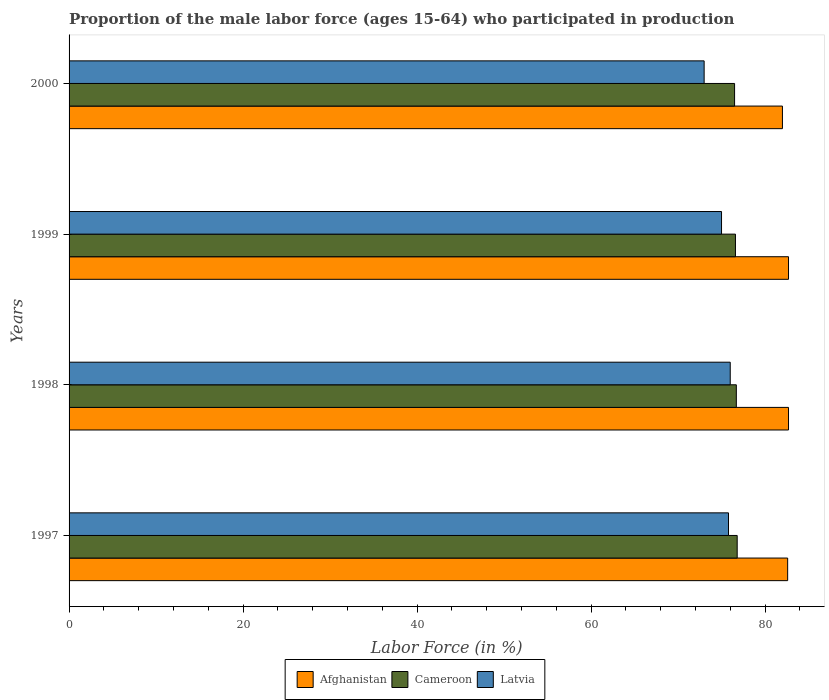How many different coloured bars are there?
Offer a terse response. 3. Are the number of bars per tick equal to the number of legend labels?
Provide a succinct answer. Yes. Are the number of bars on each tick of the Y-axis equal?
Your response must be concise. Yes. In how many cases, is the number of bars for a given year not equal to the number of legend labels?
Provide a succinct answer. 0. What is the proportion of the male labor force who participated in production in Afghanistan in 1998?
Ensure brevity in your answer.  82.7. Across all years, what is the maximum proportion of the male labor force who participated in production in Latvia?
Provide a short and direct response. 76. Across all years, what is the minimum proportion of the male labor force who participated in production in Latvia?
Offer a very short reply. 73. In which year was the proportion of the male labor force who participated in production in Afghanistan maximum?
Provide a short and direct response. 1998. In which year was the proportion of the male labor force who participated in production in Cameroon minimum?
Your answer should be compact. 2000. What is the total proportion of the male labor force who participated in production in Cameroon in the graph?
Offer a terse response. 306.6. What is the difference between the proportion of the male labor force who participated in production in Latvia in 1998 and the proportion of the male labor force who participated in production in Cameroon in 1997?
Provide a short and direct response. -0.8. What is the average proportion of the male labor force who participated in production in Cameroon per year?
Ensure brevity in your answer.  76.65. In the year 1998, what is the difference between the proportion of the male labor force who participated in production in Latvia and proportion of the male labor force who participated in production in Cameroon?
Provide a succinct answer. -0.7. What is the ratio of the proportion of the male labor force who participated in production in Latvia in 1998 to that in 1999?
Ensure brevity in your answer.  1.01. What is the difference between the highest and the second highest proportion of the male labor force who participated in production in Cameroon?
Your answer should be compact. 0.1. What is the difference between the highest and the lowest proportion of the male labor force who participated in production in Cameroon?
Make the answer very short. 0.3. Is the sum of the proportion of the male labor force who participated in production in Afghanistan in 1998 and 1999 greater than the maximum proportion of the male labor force who participated in production in Cameroon across all years?
Ensure brevity in your answer.  Yes. What does the 3rd bar from the top in 2000 represents?
Your answer should be very brief. Afghanistan. What does the 2nd bar from the bottom in 1998 represents?
Give a very brief answer. Cameroon. How many years are there in the graph?
Provide a short and direct response. 4. How are the legend labels stacked?
Offer a terse response. Horizontal. What is the title of the graph?
Your response must be concise. Proportion of the male labor force (ages 15-64) who participated in production. Does "China" appear as one of the legend labels in the graph?
Your answer should be compact. No. What is the label or title of the X-axis?
Make the answer very short. Labor Force (in %). What is the label or title of the Y-axis?
Your response must be concise. Years. What is the Labor Force (in %) of Afghanistan in 1997?
Offer a very short reply. 82.6. What is the Labor Force (in %) in Cameroon in 1997?
Give a very brief answer. 76.8. What is the Labor Force (in %) in Latvia in 1997?
Offer a very short reply. 75.8. What is the Labor Force (in %) in Afghanistan in 1998?
Your response must be concise. 82.7. What is the Labor Force (in %) in Cameroon in 1998?
Your answer should be compact. 76.7. What is the Labor Force (in %) of Latvia in 1998?
Your answer should be very brief. 76. What is the Labor Force (in %) of Afghanistan in 1999?
Make the answer very short. 82.7. What is the Labor Force (in %) of Cameroon in 1999?
Your answer should be very brief. 76.6. What is the Labor Force (in %) in Latvia in 1999?
Your answer should be compact. 75. What is the Labor Force (in %) of Afghanistan in 2000?
Your answer should be compact. 82. What is the Labor Force (in %) of Cameroon in 2000?
Your answer should be compact. 76.5. What is the Labor Force (in %) of Latvia in 2000?
Provide a succinct answer. 73. Across all years, what is the maximum Labor Force (in %) in Afghanistan?
Offer a very short reply. 82.7. Across all years, what is the maximum Labor Force (in %) in Cameroon?
Your answer should be compact. 76.8. Across all years, what is the maximum Labor Force (in %) of Latvia?
Keep it short and to the point. 76. Across all years, what is the minimum Labor Force (in %) of Afghanistan?
Your answer should be compact. 82. Across all years, what is the minimum Labor Force (in %) in Cameroon?
Give a very brief answer. 76.5. What is the total Labor Force (in %) of Afghanistan in the graph?
Your response must be concise. 330. What is the total Labor Force (in %) of Cameroon in the graph?
Offer a terse response. 306.6. What is the total Labor Force (in %) in Latvia in the graph?
Give a very brief answer. 299.8. What is the difference between the Labor Force (in %) in Cameroon in 1997 and that in 1998?
Provide a succinct answer. 0.1. What is the difference between the Labor Force (in %) of Latvia in 1997 and that in 1998?
Keep it short and to the point. -0.2. What is the difference between the Labor Force (in %) of Afghanistan in 1997 and that in 1999?
Give a very brief answer. -0.1. What is the difference between the Labor Force (in %) in Cameroon in 1997 and that in 2000?
Keep it short and to the point. 0.3. What is the difference between the Labor Force (in %) of Latvia in 1997 and that in 2000?
Offer a terse response. 2.8. What is the difference between the Labor Force (in %) in Afghanistan in 1998 and that in 1999?
Offer a terse response. 0. What is the difference between the Labor Force (in %) of Cameroon in 1998 and that in 2000?
Offer a terse response. 0.2. What is the difference between the Labor Force (in %) in Afghanistan in 1999 and that in 2000?
Your answer should be compact. 0.7. What is the difference between the Labor Force (in %) of Latvia in 1999 and that in 2000?
Offer a very short reply. 2. What is the difference between the Labor Force (in %) of Afghanistan in 1997 and the Labor Force (in %) of Cameroon in 1998?
Your answer should be very brief. 5.9. What is the difference between the Labor Force (in %) in Afghanistan in 1997 and the Labor Force (in %) in Latvia in 1999?
Offer a very short reply. 7.6. What is the difference between the Labor Force (in %) of Cameroon in 1997 and the Labor Force (in %) of Latvia in 1999?
Your answer should be very brief. 1.8. What is the difference between the Labor Force (in %) of Afghanistan in 1997 and the Labor Force (in %) of Latvia in 2000?
Give a very brief answer. 9.6. What is the difference between the Labor Force (in %) of Cameroon in 1997 and the Labor Force (in %) of Latvia in 2000?
Your response must be concise. 3.8. What is the difference between the Labor Force (in %) in Afghanistan in 1998 and the Labor Force (in %) in Latvia in 1999?
Give a very brief answer. 7.7. What is the difference between the Labor Force (in %) in Cameroon in 1998 and the Labor Force (in %) in Latvia in 1999?
Your answer should be compact. 1.7. What is the difference between the Labor Force (in %) in Afghanistan in 1998 and the Labor Force (in %) in Cameroon in 2000?
Offer a very short reply. 6.2. What is the difference between the Labor Force (in %) of Cameroon in 1999 and the Labor Force (in %) of Latvia in 2000?
Offer a very short reply. 3.6. What is the average Labor Force (in %) of Afghanistan per year?
Your answer should be very brief. 82.5. What is the average Labor Force (in %) in Cameroon per year?
Ensure brevity in your answer.  76.65. What is the average Labor Force (in %) in Latvia per year?
Provide a succinct answer. 74.95. In the year 1997, what is the difference between the Labor Force (in %) of Afghanistan and Labor Force (in %) of Latvia?
Make the answer very short. 6.8. In the year 1997, what is the difference between the Labor Force (in %) in Cameroon and Labor Force (in %) in Latvia?
Make the answer very short. 1. In the year 1998, what is the difference between the Labor Force (in %) of Afghanistan and Labor Force (in %) of Cameroon?
Your answer should be very brief. 6. In the year 1998, what is the difference between the Labor Force (in %) of Cameroon and Labor Force (in %) of Latvia?
Keep it short and to the point. 0.7. What is the ratio of the Labor Force (in %) in Afghanistan in 1997 to that in 1998?
Make the answer very short. 1. What is the ratio of the Labor Force (in %) of Cameroon in 1997 to that in 1998?
Make the answer very short. 1. What is the ratio of the Labor Force (in %) in Latvia in 1997 to that in 1998?
Give a very brief answer. 1. What is the ratio of the Labor Force (in %) of Afghanistan in 1997 to that in 1999?
Provide a short and direct response. 1. What is the ratio of the Labor Force (in %) of Latvia in 1997 to that in 1999?
Your answer should be very brief. 1.01. What is the ratio of the Labor Force (in %) in Afghanistan in 1997 to that in 2000?
Your answer should be compact. 1.01. What is the ratio of the Labor Force (in %) in Cameroon in 1997 to that in 2000?
Your response must be concise. 1. What is the ratio of the Labor Force (in %) of Latvia in 1997 to that in 2000?
Your response must be concise. 1.04. What is the ratio of the Labor Force (in %) in Cameroon in 1998 to that in 1999?
Your answer should be very brief. 1. What is the ratio of the Labor Force (in %) of Latvia in 1998 to that in 1999?
Your response must be concise. 1.01. What is the ratio of the Labor Force (in %) of Afghanistan in 1998 to that in 2000?
Give a very brief answer. 1.01. What is the ratio of the Labor Force (in %) in Cameroon in 1998 to that in 2000?
Ensure brevity in your answer.  1. What is the ratio of the Labor Force (in %) in Latvia in 1998 to that in 2000?
Keep it short and to the point. 1.04. What is the ratio of the Labor Force (in %) in Afghanistan in 1999 to that in 2000?
Make the answer very short. 1.01. What is the ratio of the Labor Force (in %) of Latvia in 1999 to that in 2000?
Ensure brevity in your answer.  1.03. What is the difference between the highest and the second highest Labor Force (in %) in Cameroon?
Your answer should be compact. 0.1. What is the difference between the highest and the lowest Labor Force (in %) in Afghanistan?
Provide a short and direct response. 0.7. 